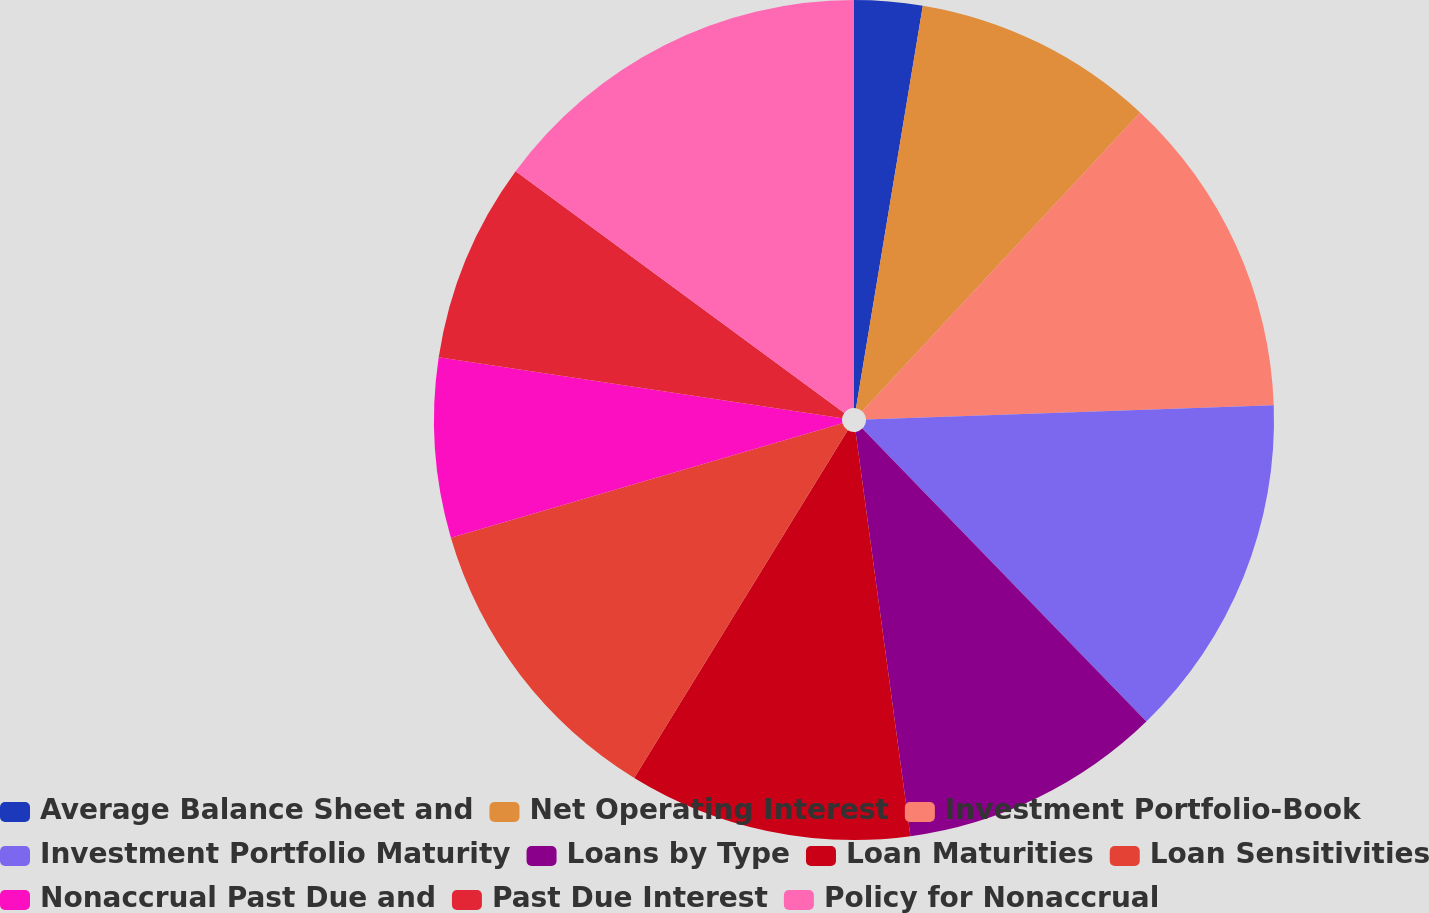<chart> <loc_0><loc_0><loc_500><loc_500><pie_chart><fcel>Average Balance Sheet and<fcel>Net Operating Interest<fcel>Investment Portfolio-Book<fcel>Investment Portfolio Maturity<fcel>Loans by Type<fcel>Loan Maturities<fcel>Loan Sensitivities<fcel>Nonaccrual Past Due and<fcel>Past Due Interest<fcel>Policy for Nonaccrual<nl><fcel>2.62%<fcel>9.31%<fcel>12.51%<fcel>13.31%<fcel>10.11%<fcel>10.91%<fcel>11.71%<fcel>6.91%<fcel>7.71%<fcel>14.91%<nl></chart> 